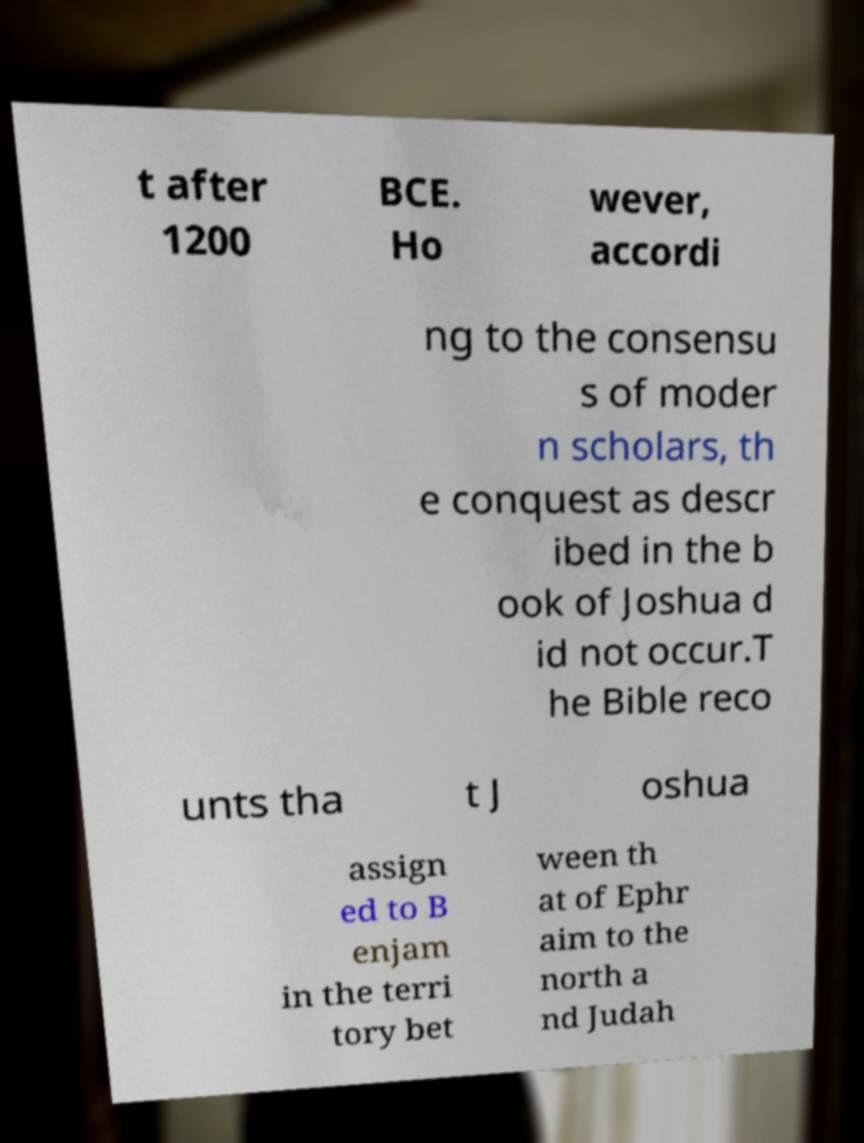For documentation purposes, I need the text within this image transcribed. Could you provide that? t after 1200 BCE. Ho wever, accordi ng to the consensu s of moder n scholars, th e conquest as descr ibed in the b ook of Joshua d id not occur.T he Bible reco unts tha t J oshua assign ed to B enjam in the terri tory bet ween th at of Ephr aim to the north a nd Judah 